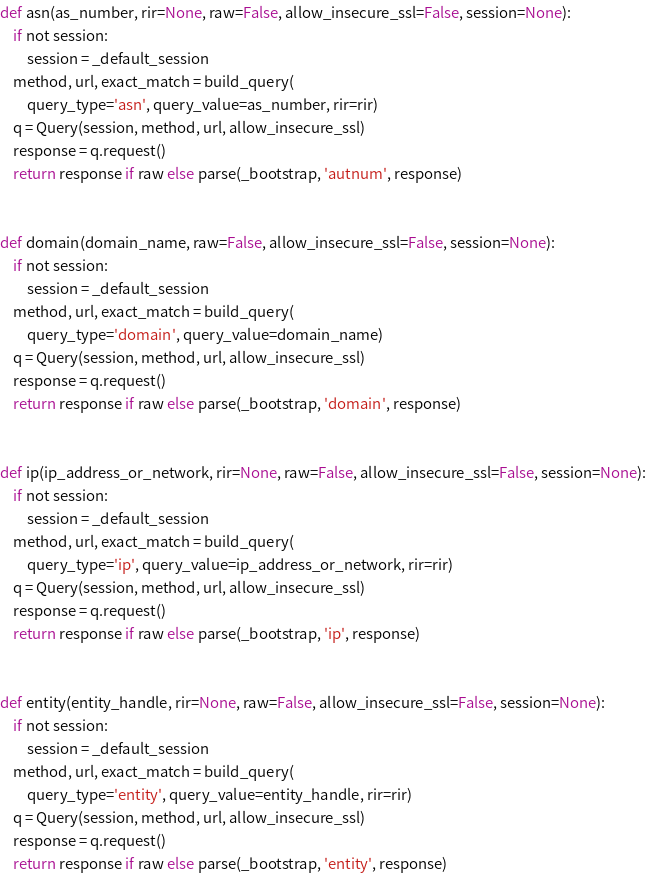Convert code to text. <code><loc_0><loc_0><loc_500><loc_500><_Python_>def asn(as_number, rir=None, raw=False, allow_insecure_ssl=False, session=None):
    if not session:
        session = _default_session
    method, url, exact_match = build_query(
        query_type='asn', query_value=as_number, rir=rir)
    q = Query(session, method, url, allow_insecure_ssl)
    response = q.request()
    return response if raw else parse(_bootstrap, 'autnum', response)


def domain(domain_name, raw=False, allow_insecure_ssl=False, session=None):
    if not session:
        session = _default_session
    method, url, exact_match = build_query(
        query_type='domain', query_value=domain_name)
    q = Query(session, method, url, allow_insecure_ssl)
    response = q.request()
    return response if raw else parse(_bootstrap, 'domain', response)


def ip(ip_address_or_network, rir=None, raw=False, allow_insecure_ssl=False, session=None):
    if not session:
        session = _default_session
    method, url, exact_match = build_query(
        query_type='ip', query_value=ip_address_or_network, rir=rir)
    q = Query(session, method, url, allow_insecure_ssl)
    response = q.request()
    return response if raw else parse(_bootstrap, 'ip', response)


def entity(entity_handle, rir=None, raw=False, allow_insecure_ssl=False, session=None):
    if not session:
        session = _default_session
    method, url, exact_match = build_query(
        query_type='entity', query_value=entity_handle, rir=rir)
    q = Query(session, method, url, allow_insecure_ssl)
    response = q.request()
    return response if raw else parse(_bootstrap, 'entity', response)
</code> 